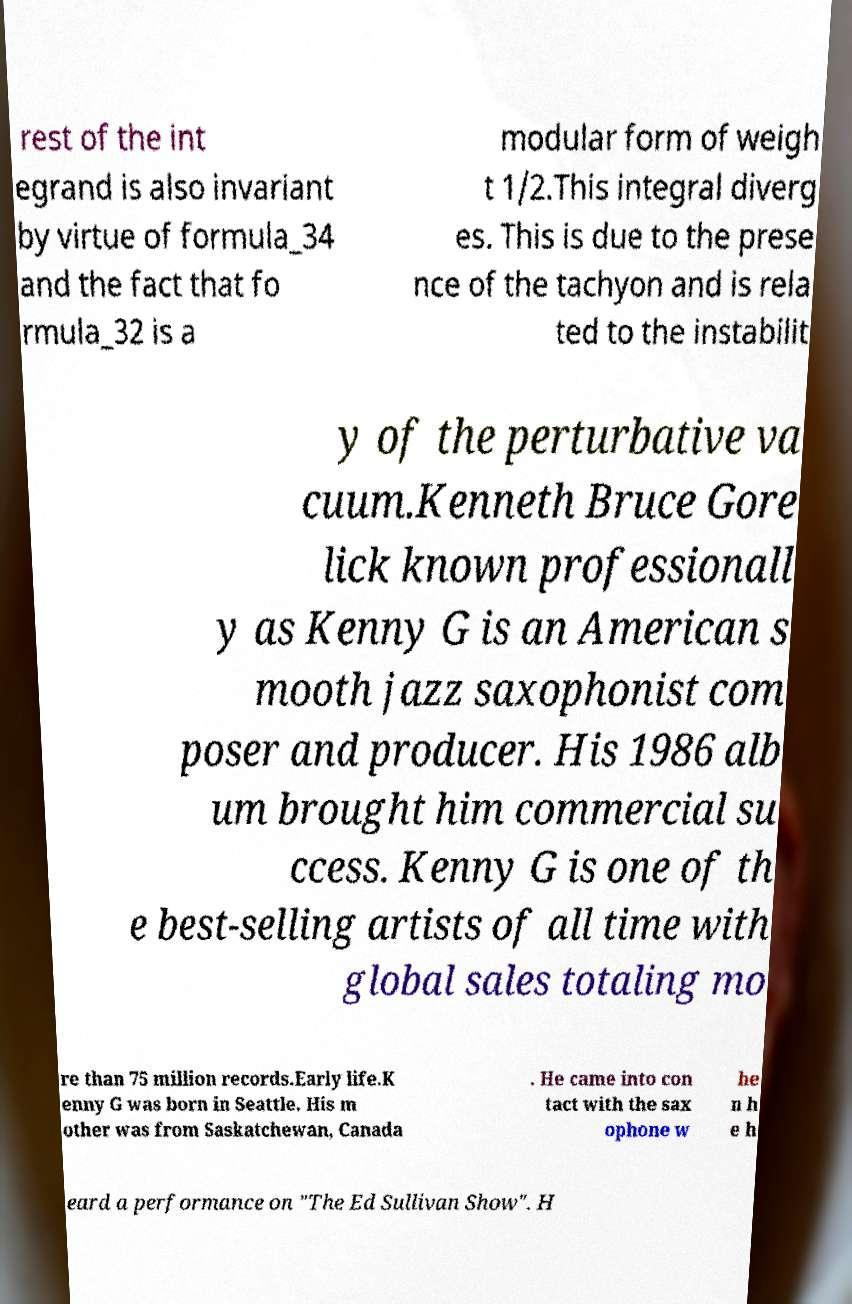What messages or text are displayed in this image? I need them in a readable, typed format. rest of the int egrand is also invariant by virtue of formula_34 and the fact that fo rmula_32 is a modular form of weigh t 1/2.This integral diverg es. This is due to the prese nce of the tachyon and is rela ted to the instabilit y of the perturbative va cuum.Kenneth Bruce Gore lick known professionall y as Kenny G is an American s mooth jazz saxophonist com poser and producer. His 1986 alb um brought him commercial su ccess. Kenny G is one of th e best-selling artists of all time with global sales totaling mo re than 75 million records.Early life.K enny G was born in Seattle. His m other was from Saskatchewan, Canada . He came into con tact with the sax ophone w he n h e h eard a performance on "The Ed Sullivan Show". H 